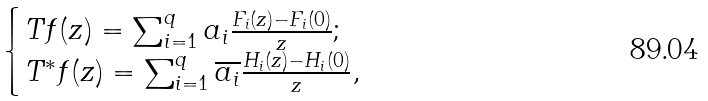<formula> <loc_0><loc_0><loc_500><loc_500>\begin{cases} T f ( z ) = \sum _ { i = 1 } ^ { q } a _ { i } \frac { F _ { i } ( z ) - F _ { i } ( 0 ) } { z } ; \\ T ^ { * } f ( z ) = \sum _ { i = 1 } ^ { q } \overline { a _ { i } } \frac { H _ { i } ( z ) - H _ { i } ( 0 ) } { z } , \end{cases}</formula> 